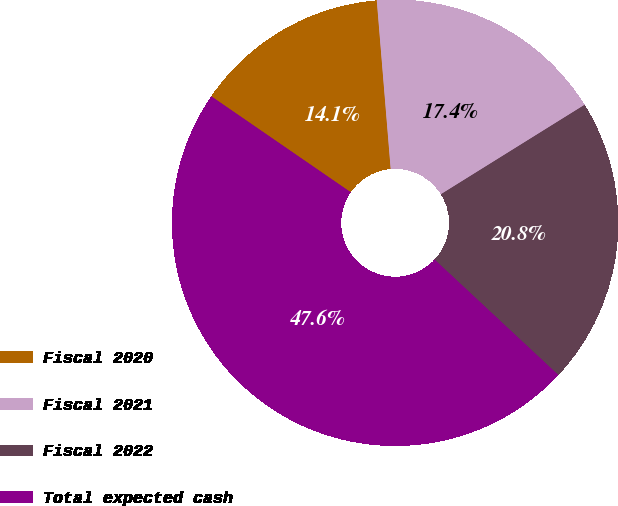Convert chart to OTSL. <chart><loc_0><loc_0><loc_500><loc_500><pie_chart><fcel>Fiscal 2020<fcel>Fiscal 2021<fcel>Fiscal 2022<fcel>Total expected cash<nl><fcel>14.1%<fcel>17.45%<fcel>20.81%<fcel>47.65%<nl></chart> 